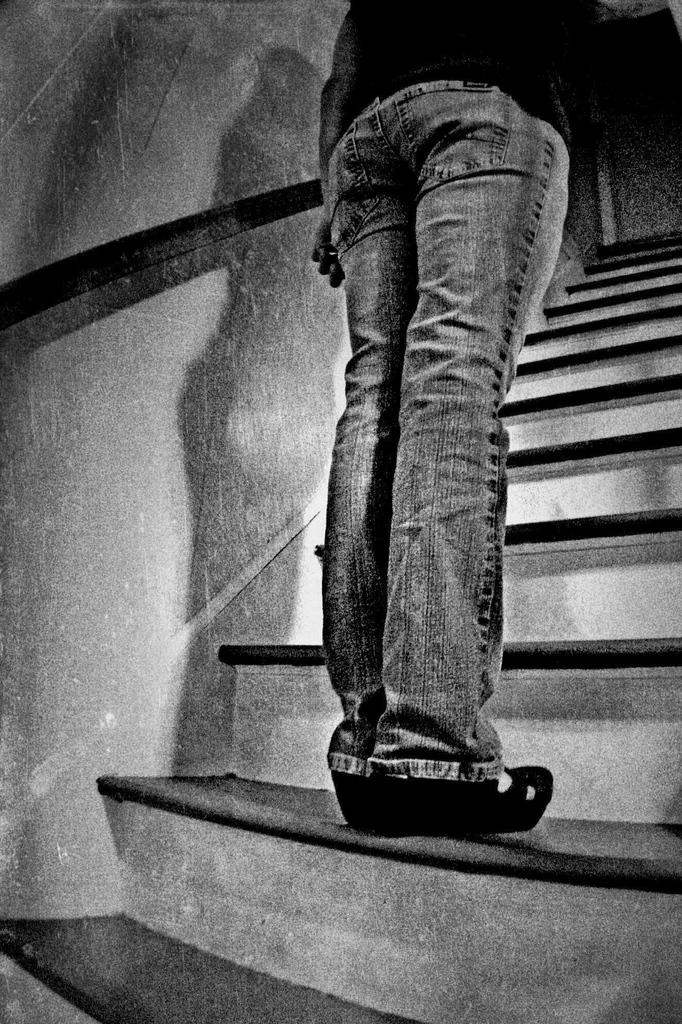What is the color scheme of the image? The image is black and white. What can be seen in the image besides the color scheme? There is a person standing in the image, as well as steps and a wall. How many children are present in the image? There are no children present in the image; it only features a person standing. What type of ear is visible on the person in the image? There is no ear visible on the person in the image, as it is a black and white photograph. 